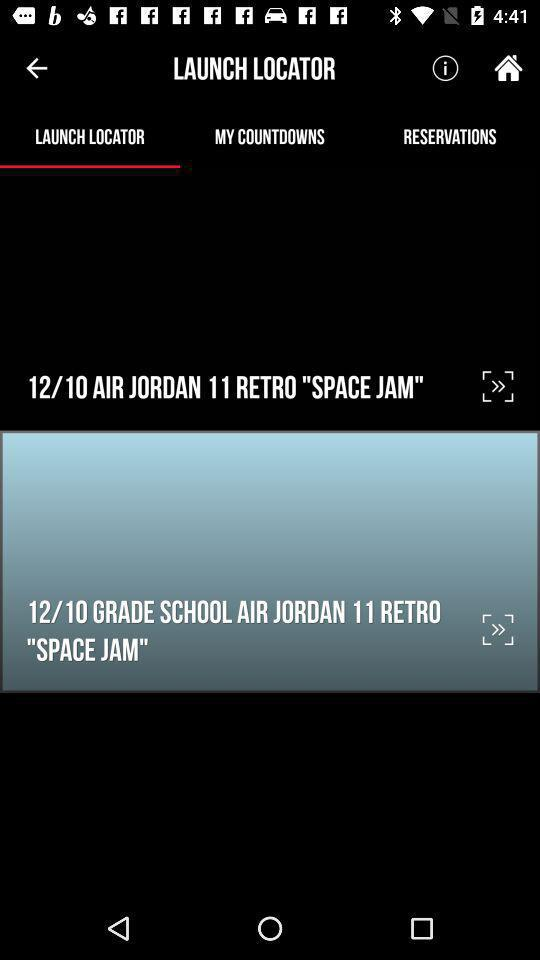What is the given application name? The application name is "Foot Locker.". 